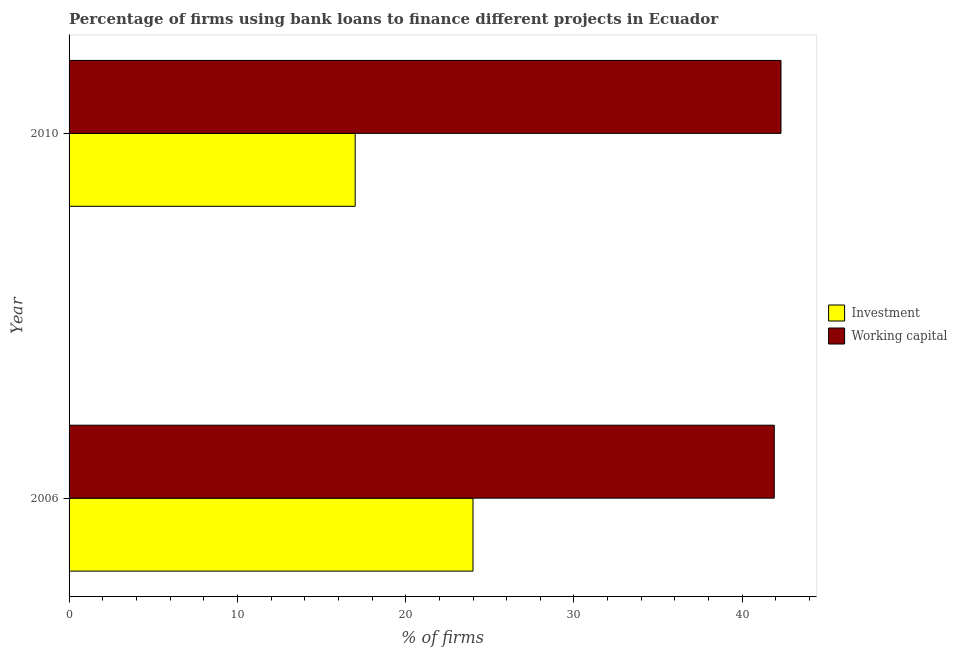How many groups of bars are there?
Ensure brevity in your answer.  2. Are the number of bars on each tick of the Y-axis equal?
Make the answer very short. Yes. How many bars are there on the 1st tick from the top?
Keep it short and to the point. 2. What is the label of the 2nd group of bars from the top?
Your answer should be very brief. 2006. In how many cases, is the number of bars for a given year not equal to the number of legend labels?
Provide a succinct answer. 0. What is the percentage of firms using banks to finance investment in 2006?
Provide a short and direct response. 24. Across all years, what is the maximum percentage of firms using banks to finance investment?
Provide a short and direct response. 24. Across all years, what is the minimum percentage of firms using banks to finance working capital?
Ensure brevity in your answer.  41.9. What is the total percentage of firms using banks to finance working capital in the graph?
Keep it short and to the point. 84.2. What is the difference between the percentage of firms using banks to finance investment in 2006 and that in 2010?
Your answer should be compact. 7. What is the difference between the percentage of firms using banks to finance working capital in 2010 and the percentage of firms using banks to finance investment in 2006?
Provide a succinct answer. 18.3. What is the average percentage of firms using banks to finance investment per year?
Provide a short and direct response. 20.5. In the year 2006, what is the difference between the percentage of firms using banks to finance investment and percentage of firms using banks to finance working capital?
Give a very brief answer. -17.9. Is the difference between the percentage of firms using banks to finance investment in 2006 and 2010 greater than the difference between the percentage of firms using banks to finance working capital in 2006 and 2010?
Your answer should be very brief. Yes. In how many years, is the percentage of firms using banks to finance investment greater than the average percentage of firms using banks to finance investment taken over all years?
Your response must be concise. 1. What does the 2nd bar from the top in 2006 represents?
Your response must be concise. Investment. What does the 2nd bar from the bottom in 2006 represents?
Offer a terse response. Working capital. Are all the bars in the graph horizontal?
Ensure brevity in your answer.  Yes. Are the values on the major ticks of X-axis written in scientific E-notation?
Provide a succinct answer. No. Does the graph contain grids?
Make the answer very short. No. Where does the legend appear in the graph?
Make the answer very short. Center right. What is the title of the graph?
Provide a short and direct response. Percentage of firms using bank loans to finance different projects in Ecuador. What is the label or title of the X-axis?
Your response must be concise. % of firms. What is the % of firms in Investment in 2006?
Offer a terse response. 24. What is the % of firms in Working capital in 2006?
Ensure brevity in your answer.  41.9. What is the % of firms of Investment in 2010?
Provide a succinct answer. 17. What is the % of firms in Working capital in 2010?
Ensure brevity in your answer.  42.3. Across all years, what is the maximum % of firms of Investment?
Your answer should be compact. 24. Across all years, what is the maximum % of firms of Working capital?
Keep it short and to the point. 42.3. Across all years, what is the minimum % of firms of Working capital?
Offer a terse response. 41.9. What is the total % of firms in Working capital in the graph?
Keep it short and to the point. 84.2. What is the difference between the % of firms in Investment in 2006 and that in 2010?
Your answer should be very brief. 7. What is the difference between the % of firms in Working capital in 2006 and that in 2010?
Provide a succinct answer. -0.4. What is the difference between the % of firms of Investment in 2006 and the % of firms of Working capital in 2010?
Your response must be concise. -18.3. What is the average % of firms in Working capital per year?
Make the answer very short. 42.1. In the year 2006, what is the difference between the % of firms of Investment and % of firms of Working capital?
Keep it short and to the point. -17.9. In the year 2010, what is the difference between the % of firms of Investment and % of firms of Working capital?
Provide a short and direct response. -25.3. What is the ratio of the % of firms in Investment in 2006 to that in 2010?
Keep it short and to the point. 1.41. What is the difference between the highest and the second highest % of firms in Working capital?
Your answer should be very brief. 0.4. 